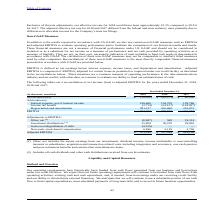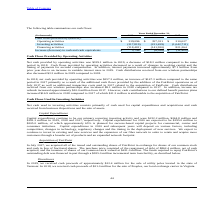According to Consolidated Communications Holdings's financial document, How is the company planning to fund the future operating requirements? cash flows from operating activities, existing cash and cash equivalents, and, if needed, from borrowings under our revolving credit facility and our ability to obtain future external financing.. The document states: "ating requirements will continue to be funded from cash flows from operating activities, existing cash and cash equivalents, and, if needed, from borr..." Also, What was the cash flow from operating activities in 2019? According to the financial document, $ 339,096 (in thousands). The relevant text states: "Operating activities $ 339,096 $ 357,321 $ 210,027..." Also, What was the cash flow provided by investing activities in 2019? According to the financial document, (217,819) (in thousands). The relevant text states: "Investing activities (217,819) (221,459) (1,042,711)..." Also, can you calculate: What was the increase / (decrease) in the cash flow from operating activities from 2018 to 2019? Based on the calculation: 339,096 - 357,321, the result is -18225 (in thousands). This is based on the information: "Operating activities $ 339,096 $ 357,321 $ 210,027 Operating activities $ 339,096 $ 357,321 $ 210,027..." The key data points involved are: 339,096, 357,321. Also, can you calculate: What was the average cash flow from investing activities for 2017-2019? To answer this question, I need to perform calculations using the financial data. The calculation is: -(217,819 + 221,459 + 1,042,711) / 3, which equals -493996.33 (in thousands). This is based on the information: "Investing activities (217,819) (221,459) (1,042,711) Investing activities (217,819) (221,459) (1,042,711) Investing activities (217,819) (221,459) (1,042,711)..." The key data points involved are: 1,042,711, 217,819, 221,459. Also, can you calculate: What was the percentage increase / (decrease) in the Increase (decrease) in cash and cash equivalents from 2018 to 2019? To answer this question, I need to perform calculations using the financial data. The calculation is: 2,796 / -6,058 - 1, which equals -146.15 (percentage). This is based on the information: "decrease) in cash and cash equivalents $ 2,796 $ (6,058) $ (11,420) ncrease (decrease) in cash and cash equivalents $ 2,796 $ (6,058) $ (11,420)..." The key data points involved are: 2,796, 6,058. 